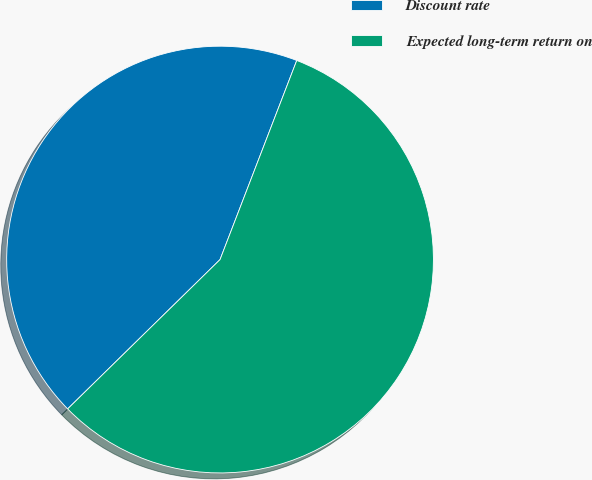Convert chart. <chart><loc_0><loc_0><loc_500><loc_500><pie_chart><fcel>Discount rate<fcel>Expected long-term return on<nl><fcel>43.19%<fcel>56.81%<nl></chart> 